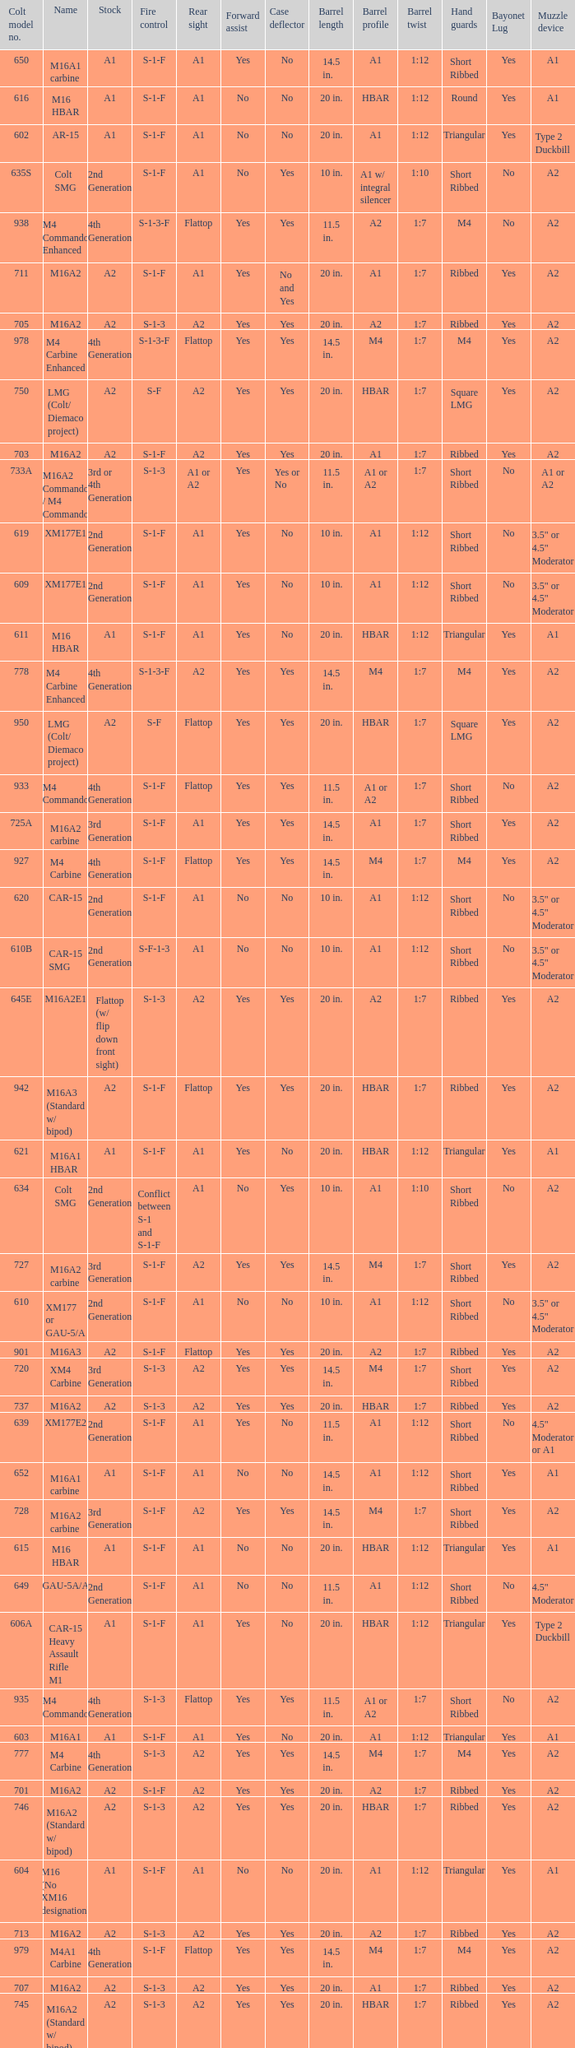What's the type of muzzle devices on the models with round hand guards? A1. 